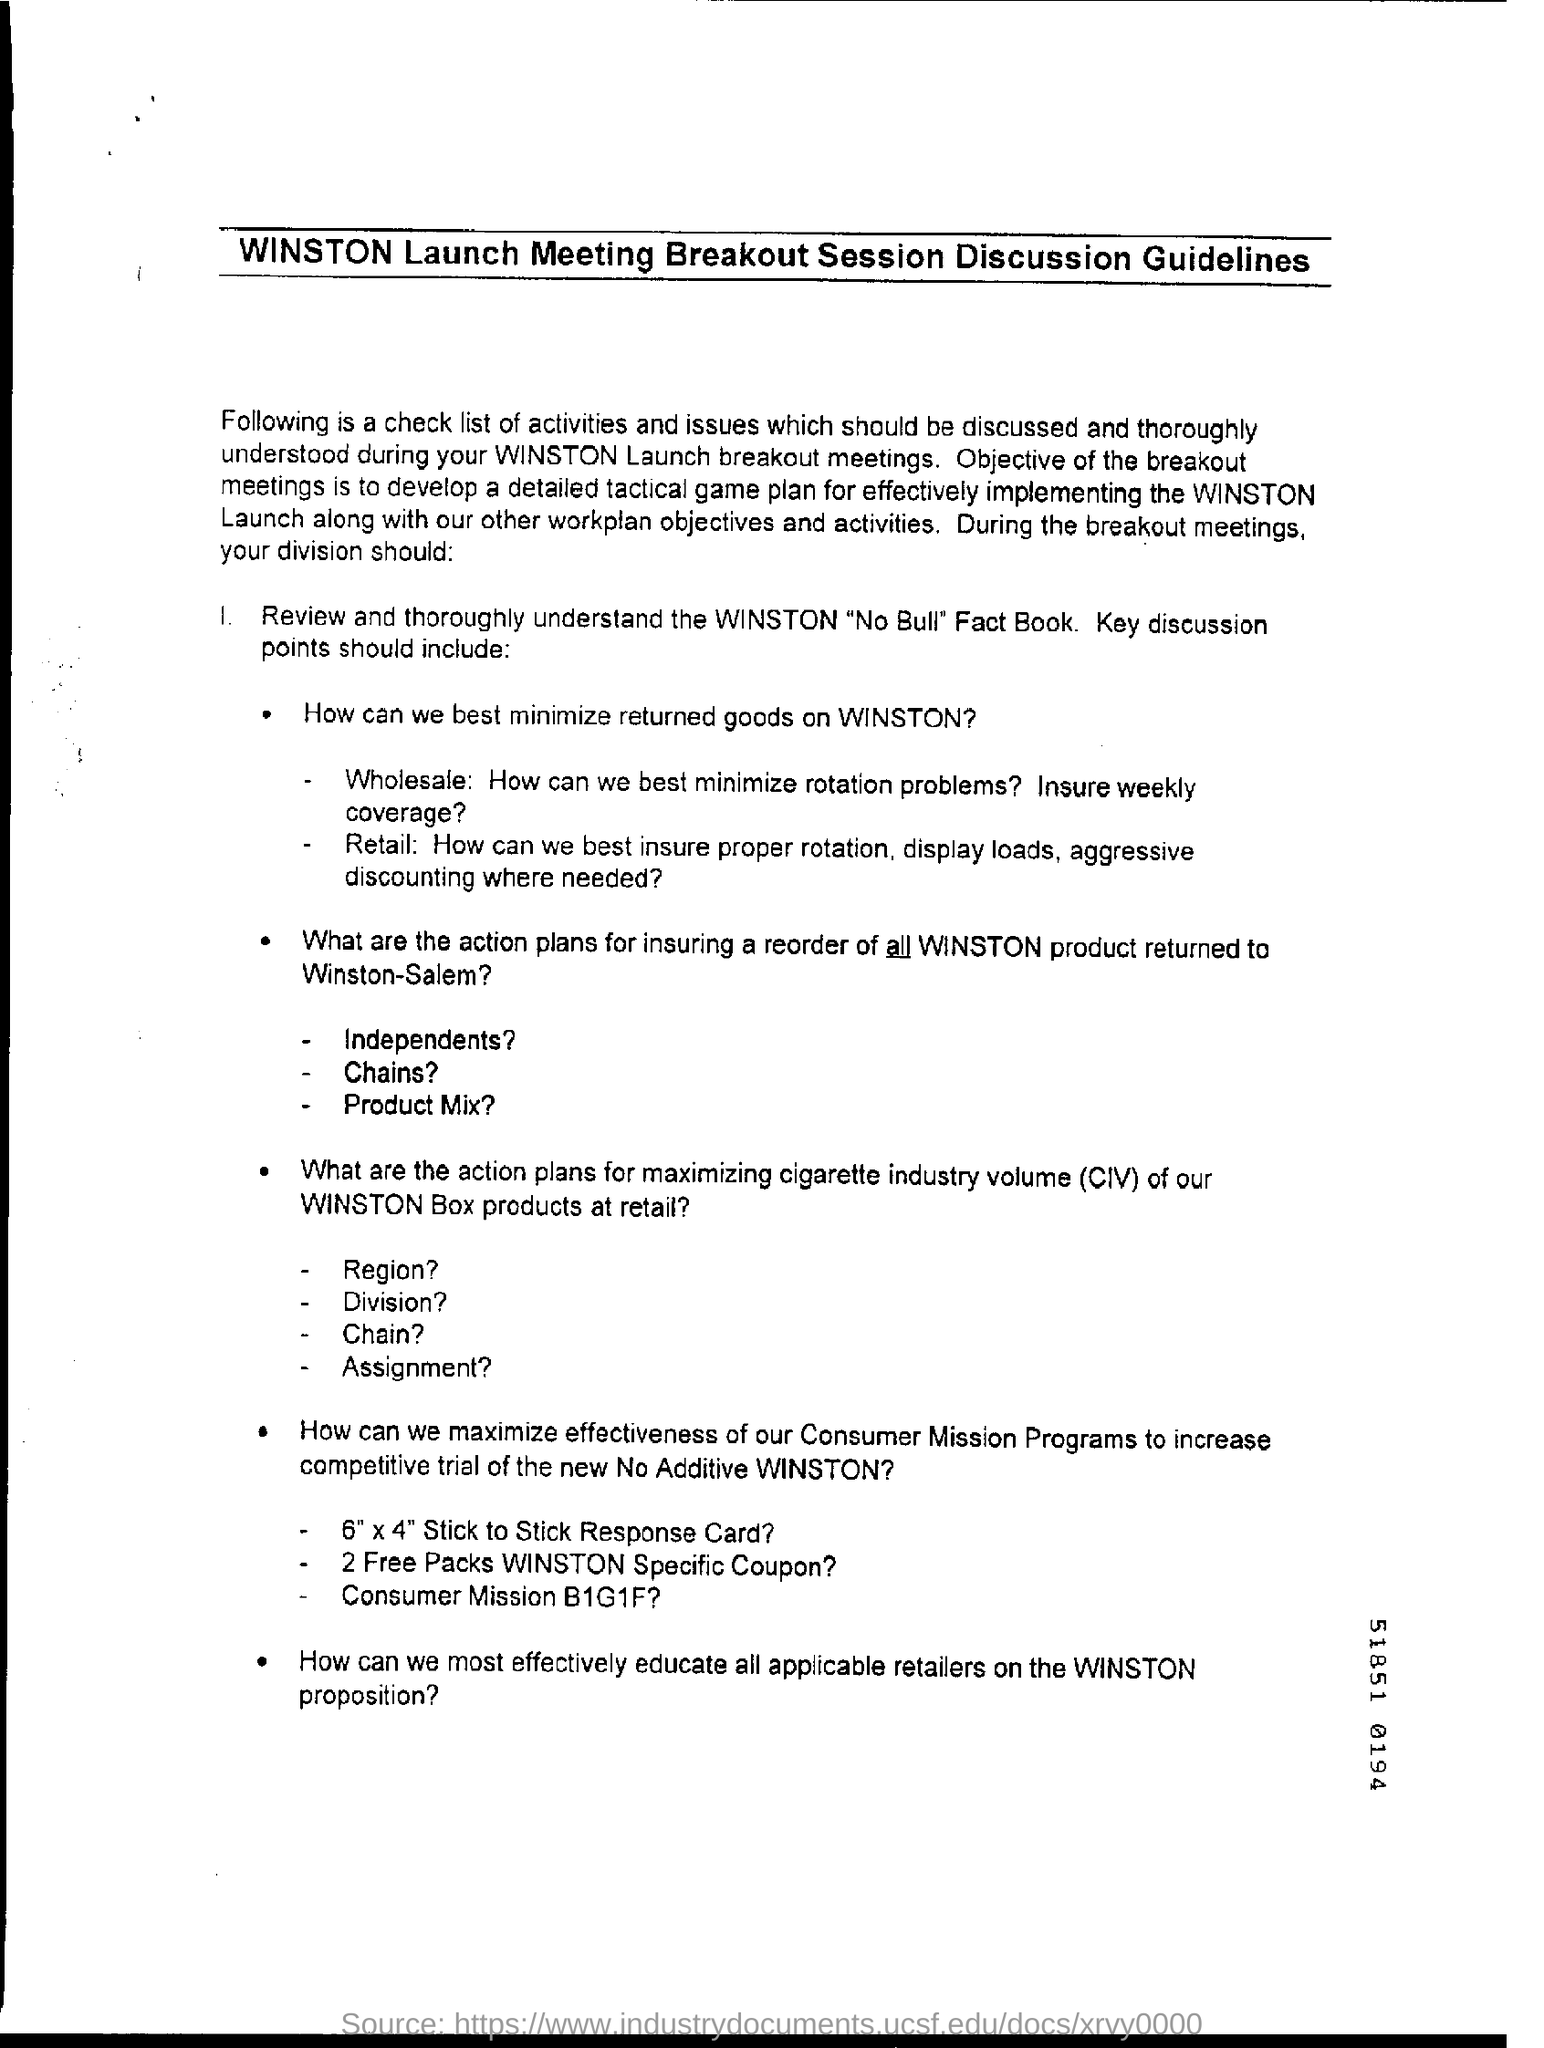What is the full form of civ?
Make the answer very short. Cigarette industry volume. 